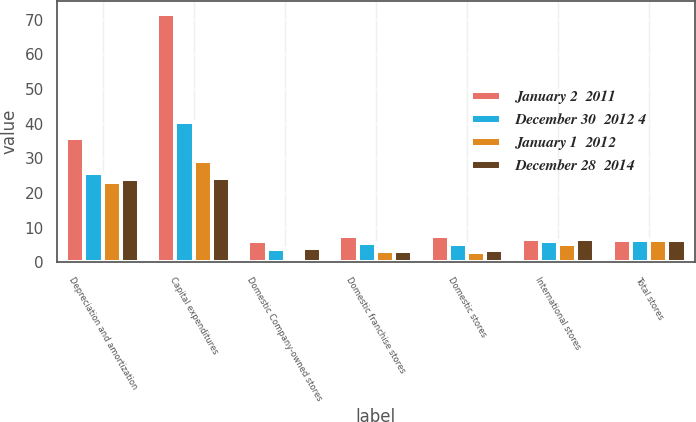<chart> <loc_0><loc_0><loc_500><loc_500><stacked_bar_chart><ecel><fcel>Depreciation and amortization<fcel>Capital expenditures<fcel>Domestic Company-owned stores<fcel>Domestic franchise stores<fcel>Domestic stores<fcel>International stores<fcel>Total stores<nl><fcel>January 2  2011<fcel>35.8<fcel>71.8<fcel>6.2<fcel>7.7<fcel>7.5<fcel>6.9<fcel>6.5<nl><fcel>December 30  2012 4<fcel>25.8<fcel>40.4<fcel>3.9<fcel>5.5<fcel>5.4<fcel>6.2<fcel>6.5<nl><fcel>January 1  2012<fcel>23.2<fcel>29.3<fcel>1.3<fcel>3.2<fcel>3.1<fcel>5.2<fcel>6.5<nl><fcel>December 28  2014<fcel>24<fcel>24.3<fcel>4.1<fcel>3.4<fcel>3.5<fcel>6.8<fcel>6.5<nl></chart> 